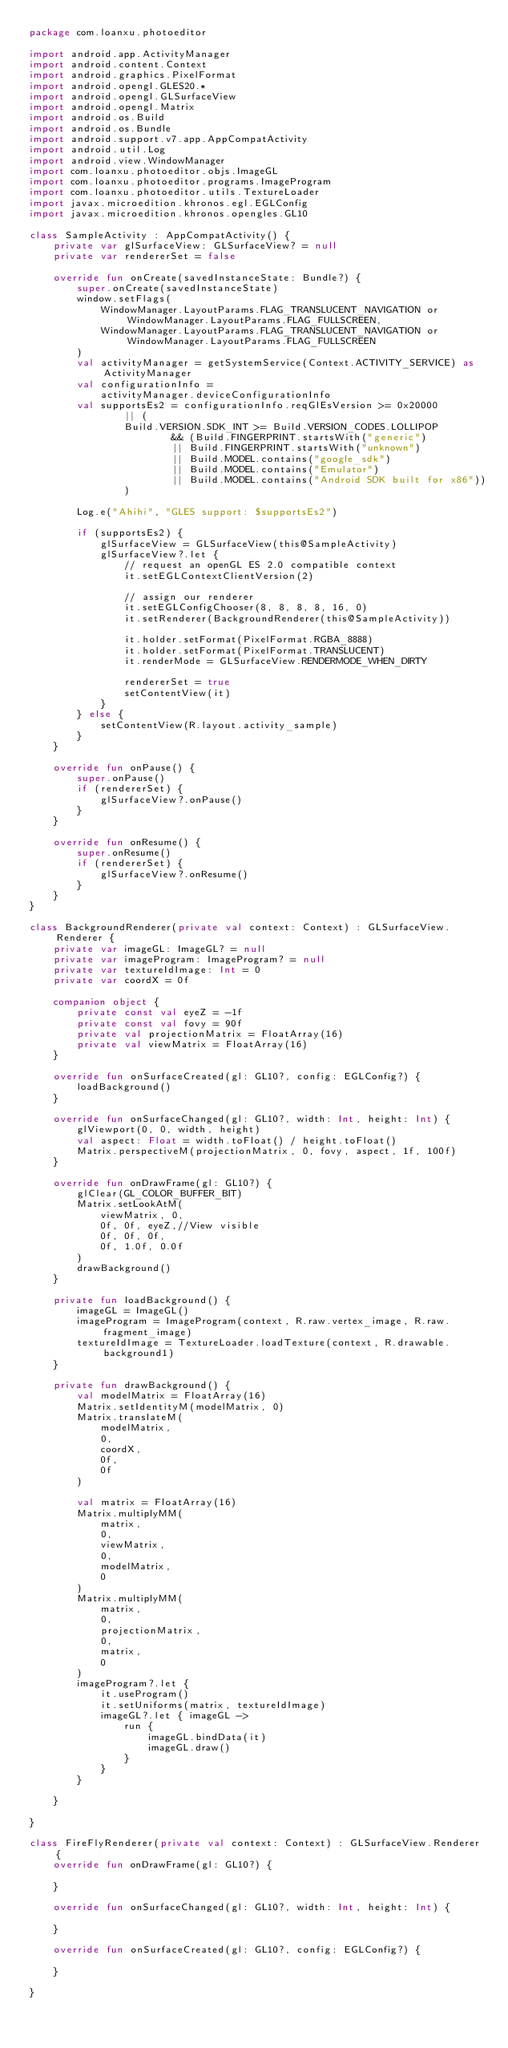<code> <loc_0><loc_0><loc_500><loc_500><_Kotlin_>package com.loanxu.photoeditor

import android.app.ActivityManager
import android.content.Context
import android.graphics.PixelFormat
import android.opengl.GLES20.*
import android.opengl.GLSurfaceView
import android.opengl.Matrix
import android.os.Build
import android.os.Bundle
import android.support.v7.app.AppCompatActivity
import android.util.Log
import android.view.WindowManager
import com.loanxu.photoeditor.objs.ImageGL
import com.loanxu.photoeditor.programs.ImageProgram
import com.loanxu.photoeditor.utils.TextureLoader
import javax.microedition.khronos.egl.EGLConfig
import javax.microedition.khronos.opengles.GL10

class SampleActivity : AppCompatActivity() {
    private var glSurfaceView: GLSurfaceView? = null
    private var rendererSet = false

    override fun onCreate(savedInstanceState: Bundle?) {
        super.onCreate(savedInstanceState)
        window.setFlags(
            WindowManager.LayoutParams.FLAG_TRANSLUCENT_NAVIGATION or WindowManager.LayoutParams.FLAG_FULLSCREEN,
            WindowManager.LayoutParams.FLAG_TRANSLUCENT_NAVIGATION or WindowManager.LayoutParams.FLAG_FULLSCREEN
        )
        val activityManager = getSystemService(Context.ACTIVITY_SERVICE) as ActivityManager
        val configurationInfo =
            activityManager.deviceConfigurationInfo
        val supportsEs2 = configurationInfo.reqGlEsVersion >= 0x20000
                || (
                Build.VERSION.SDK_INT >= Build.VERSION_CODES.LOLLIPOP
                        && (Build.FINGERPRINT.startsWith("generic")
                        || Build.FINGERPRINT.startsWith("unknown")
                        || Build.MODEL.contains("google_sdk")
                        || Build.MODEL.contains("Emulator")
                        || Build.MODEL.contains("Android SDK built for x86"))
                )

        Log.e("Ahihi", "GLES support: $supportsEs2")

        if (supportsEs2) {
            glSurfaceView = GLSurfaceView(this@SampleActivity)
            glSurfaceView?.let {
                // request an openGL ES 2.0 compatible context
                it.setEGLContextClientVersion(2)

                // assign our renderer
                it.setEGLConfigChooser(8, 8, 8, 8, 16, 0)
                it.setRenderer(BackgroundRenderer(this@SampleActivity))

                it.holder.setFormat(PixelFormat.RGBA_8888)
                it.holder.setFormat(PixelFormat.TRANSLUCENT)
                it.renderMode = GLSurfaceView.RENDERMODE_WHEN_DIRTY

                rendererSet = true
                setContentView(it)
            }
        } else {
            setContentView(R.layout.activity_sample)
        }
    }

    override fun onPause() {
        super.onPause()
        if (rendererSet) {
            glSurfaceView?.onPause()
        }
    }

    override fun onResume() {
        super.onResume()
        if (rendererSet) {
            glSurfaceView?.onResume()
        }
    }
}

class BackgroundRenderer(private val context: Context) : GLSurfaceView.Renderer {
    private var imageGL: ImageGL? = null
    private var imageProgram: ImageProgram? = null
    private var textureIdImage: Int = 0
    private var coordX = 0f

    companion object {
        private const val eyeZ = -1f
        private const val fovy = 90f
        private val projectionMatrix = FloatArray(16)
        private val viewMatrix = FloatArray(16)
    }

    override fun onSurfaceCreated(gl: GL10?, config: EGLConfig?) {
        loadBackground()
    }

    override fun onSurfaceChanged(gl: GL10?, width: Int, height: Int) {
        glViewport(0, 0, width, height)
        val aspect: Float = width.toFloat() / height.toFloat()
        Matrix.perspectiveM(projectionMatrix, 0, fovy, aspect, 1f, 100f)
    }

    override fun onDrawFrame(gl: GL10?) {
        glClear(GL_COLOR_BUFFER_BIT)
        Matrix.setLookAtM(
            viewMatrix, 0,
            0f, 0f, eyeZ,//View visible
            0f, 0f, 0f,
            0f, 1.0f, 0.0f
        )
        drawBackground()
    }

    private fun loadBackground() {
        imageGL = ImageGL()
        imageProgram = ImageProgram(context, R.raw.vertex_image, R.raw.fragment_image)
        textureIdImage = TextureLoader.loadTexture(context, R.drawable.background1)
    }

    private fun drawBackground() {
        val modelMatrix = FloatArray(16)
        Matrix.setIdentityM(modelMatrix, 0)
        Matrix.translateM(
            modelMatrix,
            0,
            coordX,
            0f,
            0f
        )

        val matrix = FloatArray(16)
        Matrix.multiplyMM(
            matrix,
            0,
            viewMatrix,
            0,
            modelMatrix,
            0
        )
        Matrix.multiplyMM(
            matrix,
            0,
            projectionMatrix,
            0,
            matrix,
            0
        )
        imageProgram?.let {
            it.useProgram()
            it.setUniforms(matrix, textureIdImage)
            imageGL?.let { imageGL ->
                run {
                    imageGL.bindData(it)
                    imageGL.draw()
                }
            }
        }

    }

}

class FireFlyRenderer(private val context: Context) : GLSurfaceView.Renderer {
    override fun onDrawFrame(gl: GL10?) {
        
    }

    override fun onSurfaceChanged(gl: GL10?, width: Int, height: Int) {
        
    }

    override fun onSurfaceCreated(gl: GL10?, config: EGLConfig?) {
        
    }

}
</code> 